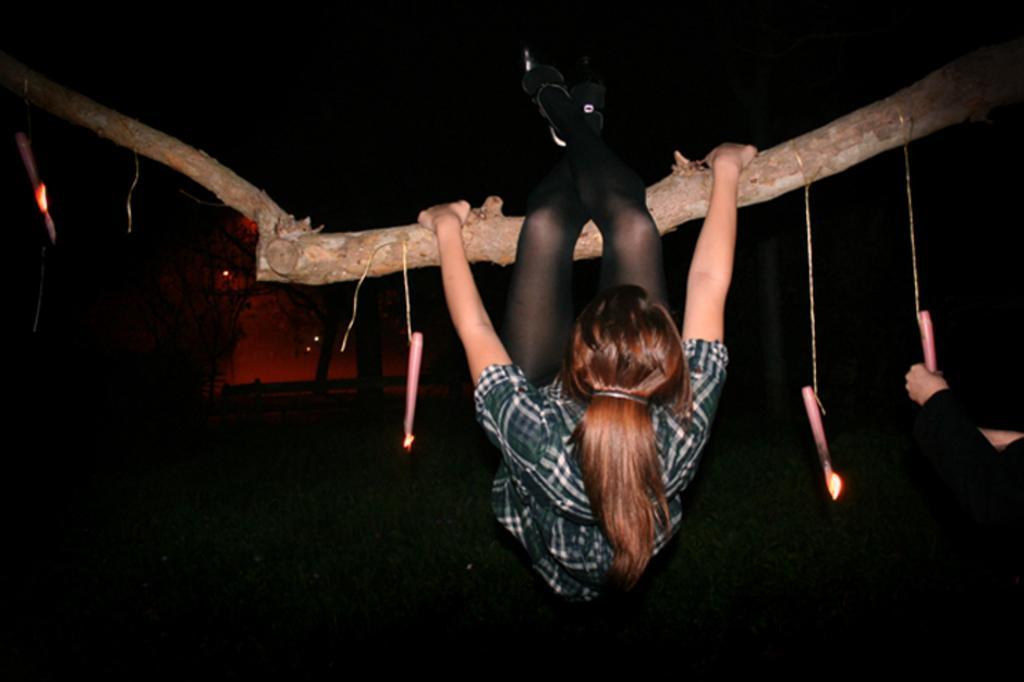Please provide a concise description of this image. In this image we can see two persons one woman is holding a branch of a tree with her hands, group of candles is tied with ropes on the branch of a tree. In the background, we can see some trees. 